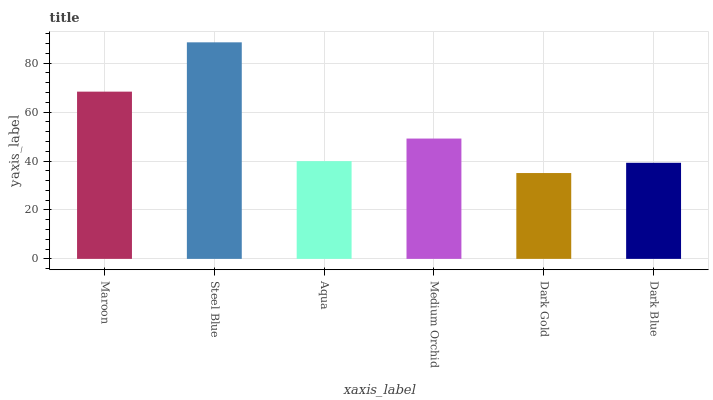Is Dark Gold the minimum?
Answer yes or no. Yes. Is Steel Blue the maximum?
Answer yes or no. Yes. Is Aqua the minimum?
Answer yes or no. No. Is Aqua the maximum?
Answer yes or no. No. Is Steel Blue greater than Aqua?
Answer yes or no. Yes. Is Aqua less than Steel Blue?
Answer yes or no. Yes. Is Aqua greater than Steel Blue?
Answer yes or no. No. Is Steel Blue less than Aqua?
Answer yes or no. No. Is Medium Orchid the high median?
Answer yes or no. Yes. Is Aqua the low median?
Answer yes or no. Yes. Is Maroon the high median?
Answer yes or no. No. Is Dark Blue the low median?
Answer yes or no. No. 